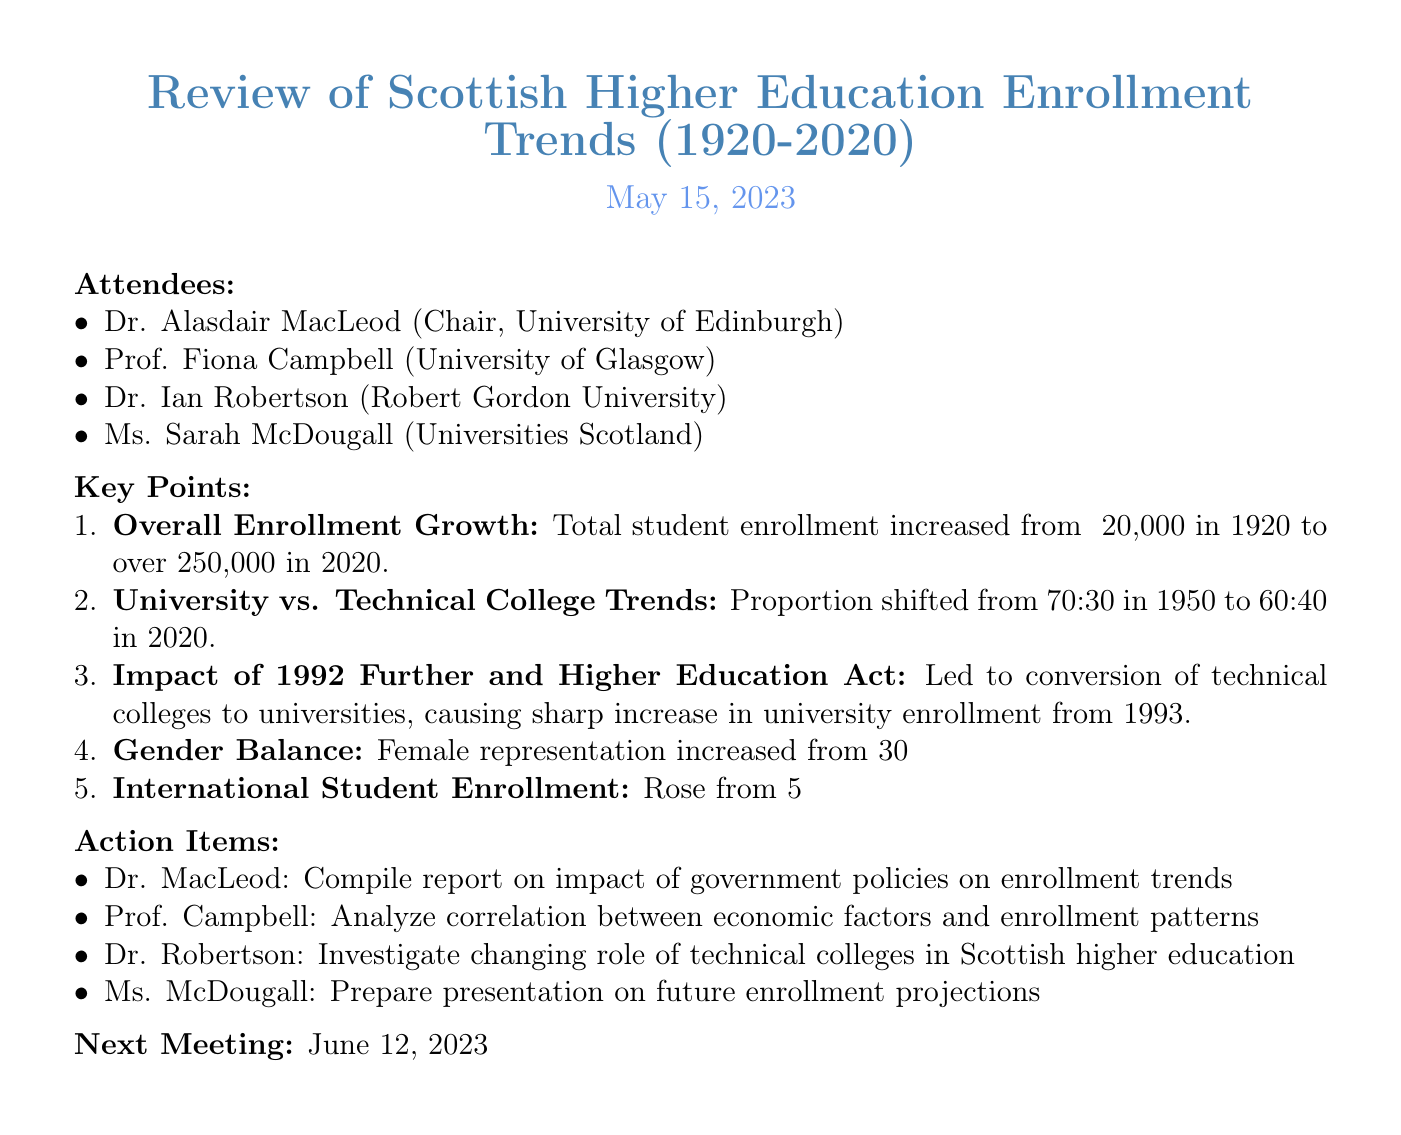what was the total student enrollment in 1920? The document states that total student enrollment in Scottish higher education institutions was approximately 20,000 in 1920.
Answer: approximately 20,000 what was the total student enrollment in 2020? According to the document, the total student enrollment increased to over 250,000 in 2020.
Answer: over 250,000 what was the male to female student representation ratio in 1950? The document indicates that female student representation was 30% in 1950, implying male representation was 70%.
Answer: 30% what was the percentage of international students in Scottish higher education in 1980? The document reports that the percentage of international students rose to 5% in 1980.
Answer: 5% who is preparing the presentation on future enrollment projections? Ms. Sarah McDougall is assigned to prepare a presentation on future enrollment projections based on historical data.
Answer: Ms. McDougall how did the proportion of students enrolled in universities change from 1950 to 2020? The document mentions that the proportion of students enrolled in universities shifted from 70:30 in 1950 to 60:40 in 2020.
Answer: 70:30 to 60:40 what significant act impacted enrollment trends from 1993 onwards? The document refers to the 1992 Further and Higher Education Act as a significant factor impacting enrollment trends.
Answer: 1992 Further and Higher Education Act when is the next meeting scheduled? The document provides the date for the next meeting, which is scheduled for June 12, 2023.
Answer: June 12, 2023 